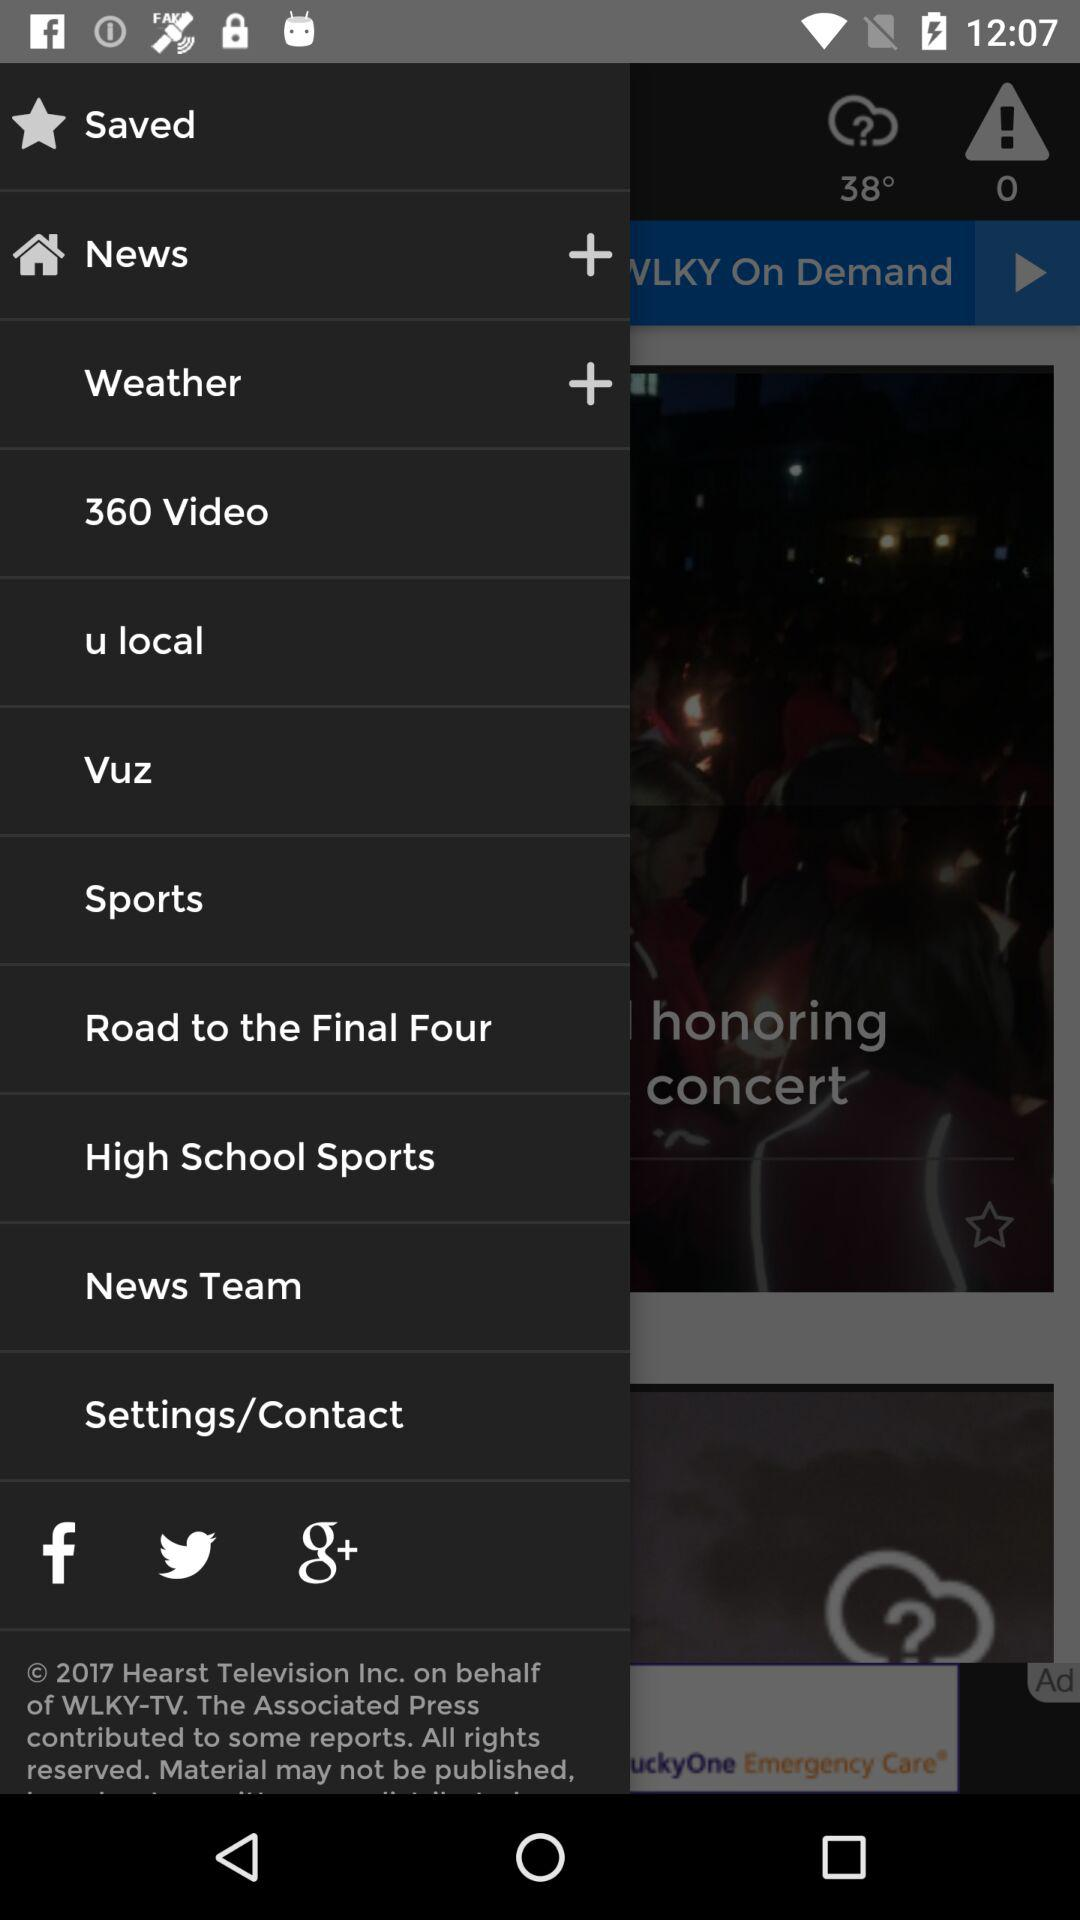Which option has a "+" sign? The options containing the "+" sign are "News" and "Weather". 